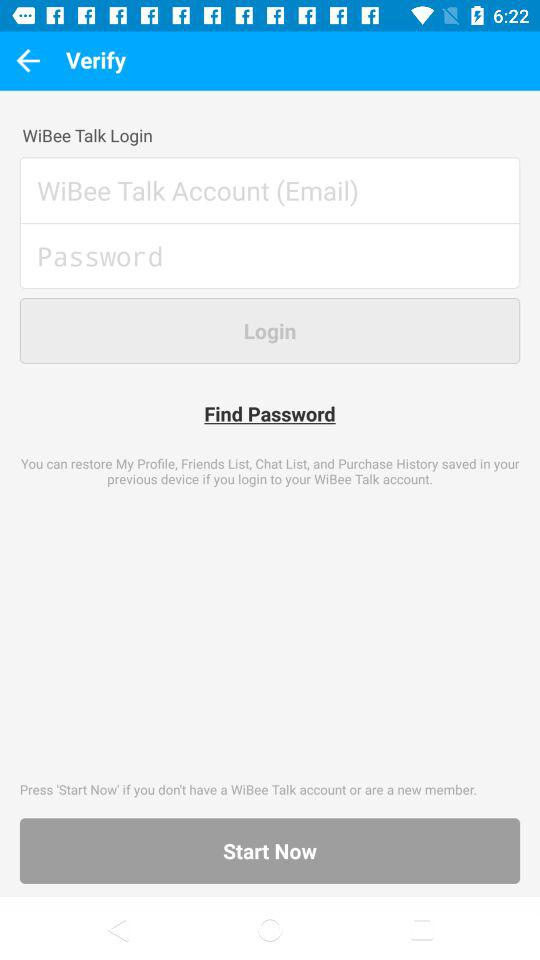How many text inputs are required to login?
Answer the question using a single word or phrase. 2 